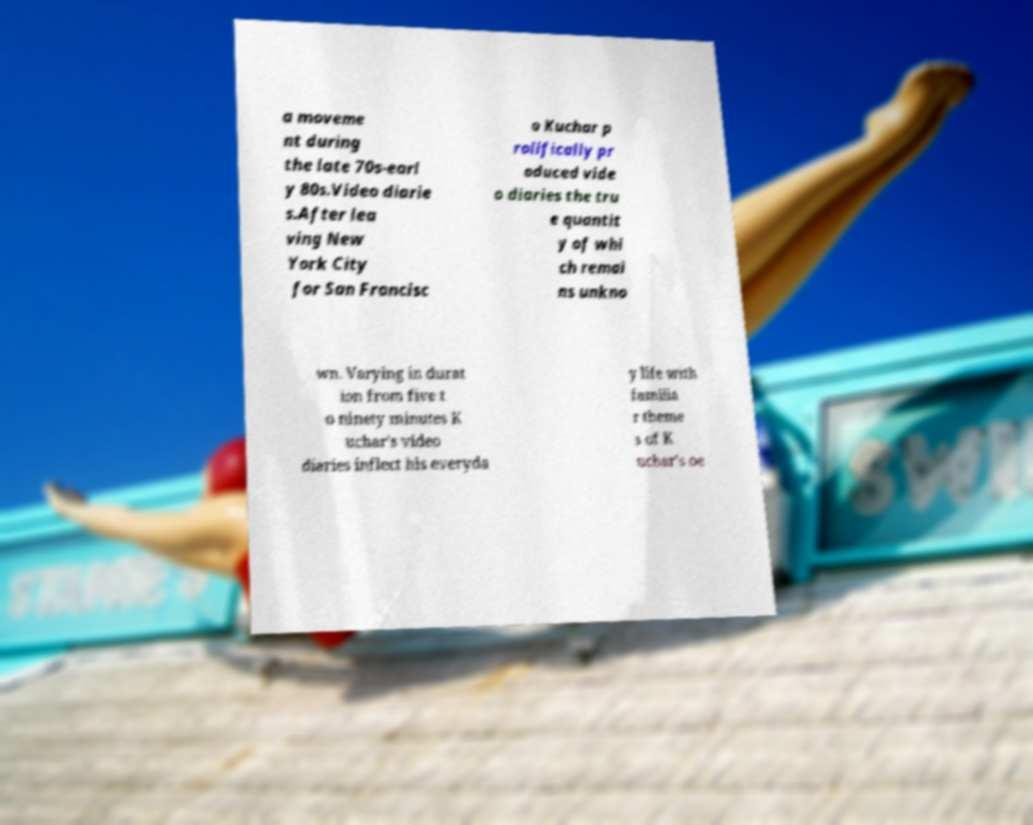Could you assist in decoding the text presented in this image and type it out clearly? a moveme nt during the late 70s-earl y 80s.Video diarie s.After lea ving New York City for San Francisc o Kuchar p rolifically pr oduced vide o diaries the tru e quantit y of whi ch remai ns unkno wn. Varying in durat ion from five t o ninety minutes K uchar's video diaries inflect his everyda y life with familia r theme s of K uchar's oe 